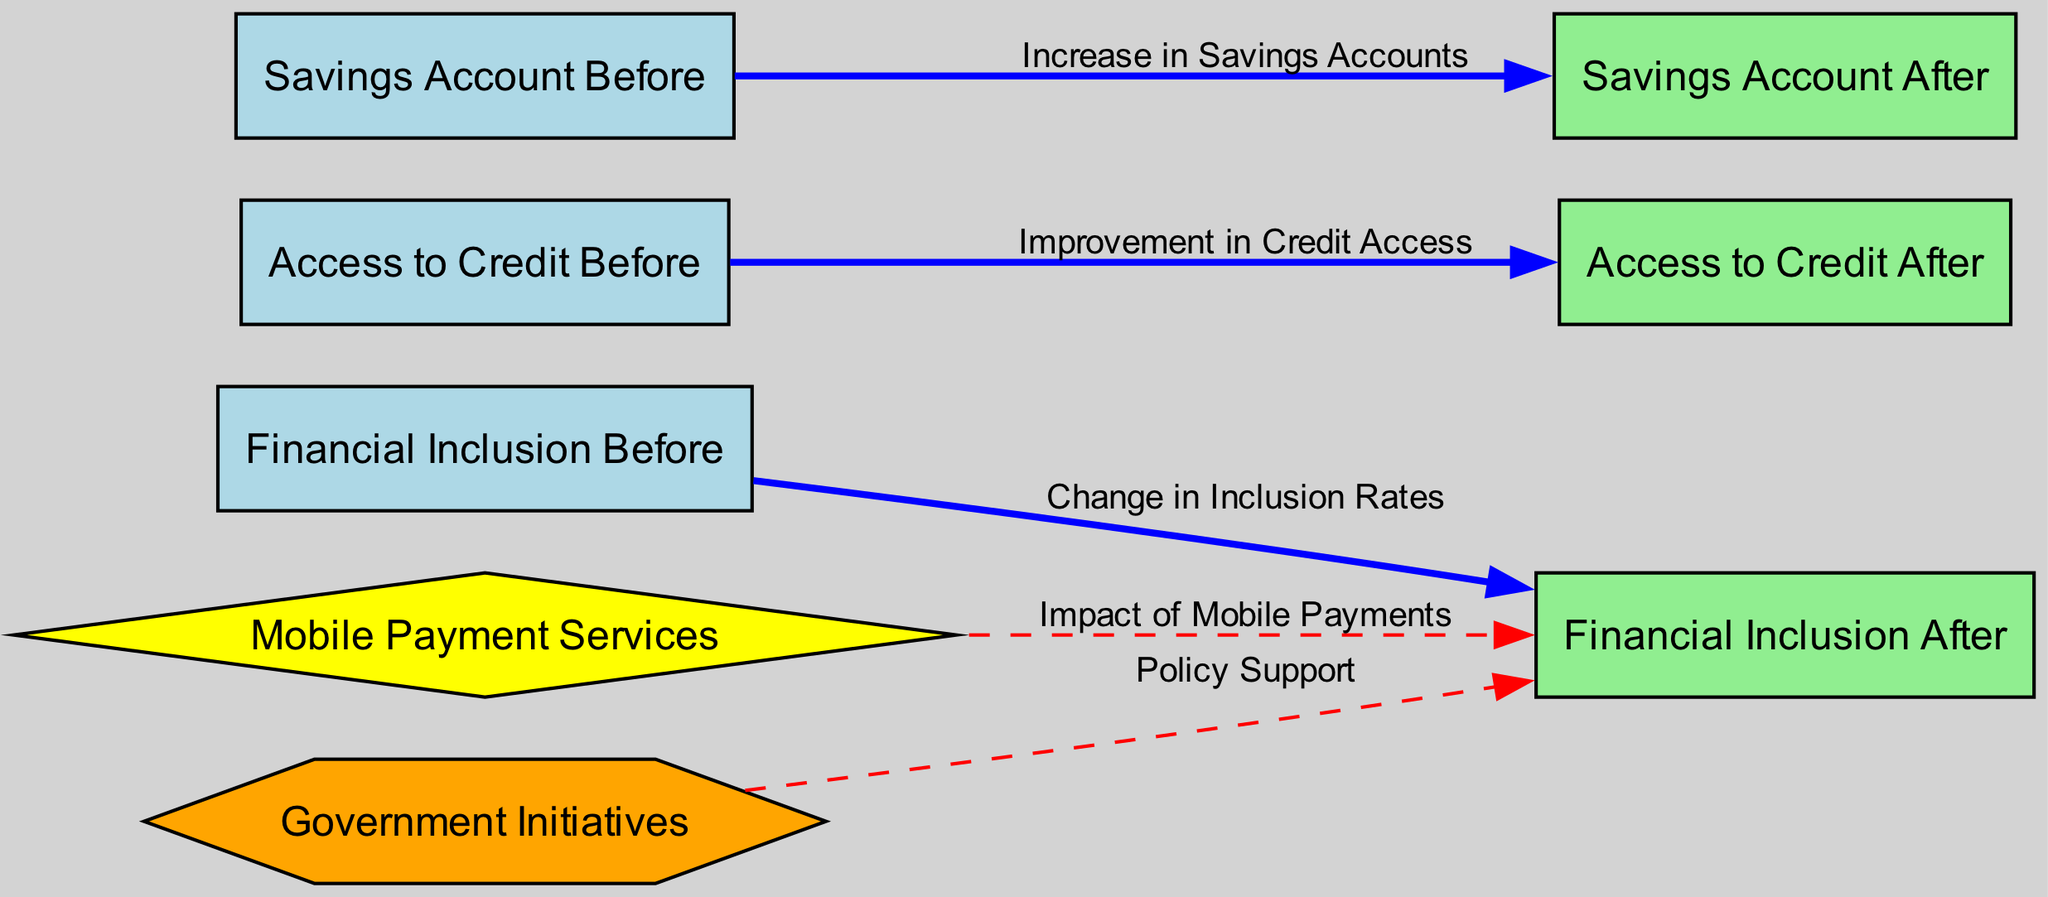What is the label of the node representing financial inclusion before fintech implementation? The diagram includes a node labeled "Financial Inclusion Before," which clearly indicates the state of financial inclusion prior to any fintech initiatives.
Answer: Financial Inclusion Before How many nodes are present in the diagram? The diagram contains eight nodes: financial inclusion before, financial inclusion after, access to credit before, access to credit after, savings account before, savings account after, mobile payment services, and government initiatives. By counting these nodes, we confirm the total number.
Answer: Eight What type of impact do mobile payment services have on financial inclusion after implementation? The diagram shows a directed edge labeled "Impact of Mobile Payments" connecting mobile payment services to financial inclusion after. This indicates a positive influence of mobile payment services on financial inclusion in rural areas.
Answer: Positive influence What is indicated by the connection from savings account before to savings account after? The edge labeled "Increase in Savings Accounts" clearly indicates an upward trend or positive change in the number of savings accounts after fintech implementation compared to before.
Answer: Increase What type of nodes are connected to financial inclusion after? Two nodes, mobile payment services and government initiatives, connect to financial inclusion after. The mobile payment services node is a diamond shape while the government initiatives node is a hexagon shape. This diversity in shapes reflects different types of influences on financial inclusion after fintech implementation.
Answer: Mobile payment services and government initiatives Explain the relationship between access to credit before and after fintech implementation. The diagram shows an edge labeled "Improvement in Credit Access" flowing from access to credit before to access to credit after. This indicates a positive shift in access to credit that occurred following the implementation of fintech solutions.
Answer: Improvement in Credit Access What does the dashed edge from government initiatives to financial inclusion after signify? The dashed edge indicates a less direct impact or variable relationship between government initiatives and financial inclusion. It suggests that while government initiatives are influencing financial inclusion after, the nature of this influence isn't as strong or direct as those indicated by solid edges in the diagram.
Answer: Variable impact Which node has a diamond shape, and what does it represent? The node "Mobile Payment Services" is represented as a diamond shape. This shape signifies it as a special type of service that directly impacts the financial landscape in rural areas, particularly regarding inclusion efforts.
Answer: Mobile Payment Services What change is represented by the edge from financial inclusion before to financial inclusion after? The edge is labeled "Change in Inclusion Rates," which indicates a shift in the rates of financial inclusion in rural areas after the introduction of fintech services compared to before their implementation.
Answer: Change in Inclusion Rates 